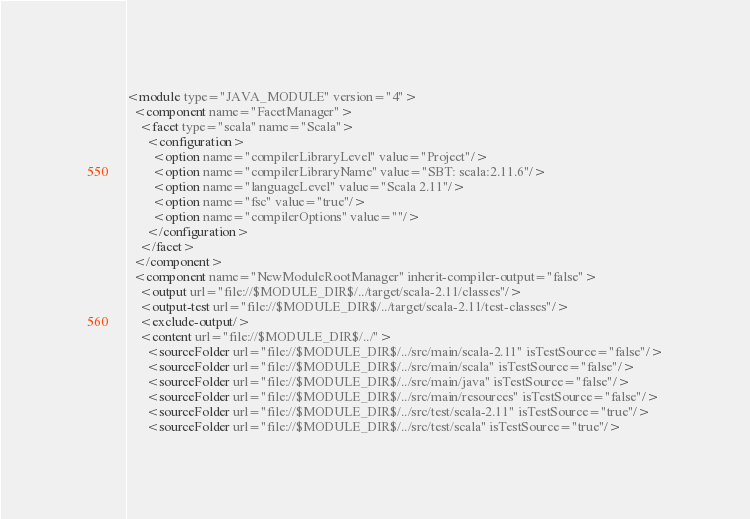Convert code to text. <code><loc_0><loc_0><loc_500><loc_500><_XML_><module type="JAVA_MODULE" version="4">
  <component name="FacetManager">
    <facet type="scala" name="Scala">
      <configuration>
        <option name="compilerLibraryLevel" value="Project"/>
        <option name="compilerLibraryName" value="SBT: scala:2.11.6"/>
        <option name="languageLevel" value="Scala 2.11"/>
        <option name="fsc" value="true"/>
        <option name="compilerOptions" value=""/>
      </configuration>
    </facet>
  </component>
  <component name="NewModuleRootManager" inherit-compiler-output="false">
    <output url="file://$MODULE_DIR$/../target/scala-2.11/classes"/>
    <output-test url="file://$MODULE_DIR$/../target/scala-2.11/test-classes"/>
    <exclude-output/>
    <content url="file://$MODULE_DIR$/../">
      <sourceFolder url="file://$MODULE_DIR$/../src/main/scala-2.11" isTestSource="false"/>
      <sourceFolder url="file://$MODULE_DIR$/../src/main/scala" isTestSource="false"/>
      <sourceFolder url="file://$MODULE_DIR$/../src/main/java" isTestSource="false"/>
      <sourceFolder url="file://$MODULE_DIR$/../src/main/resources" isTestSource="false"/>
      <sourceFolder url="file://$MODULE_DIR$/../src/test/scala-2.11" isTestSource="true"/>
      <sourceFolder url="file://$MODULE_DIR$/../src/test/scala" isTestSource="true"/></code> 